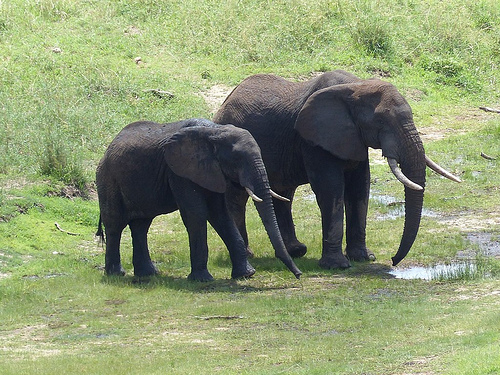Is it an outdoors or indoors picture? This is an outdoors picture, clearly showcasing the natural environment. 